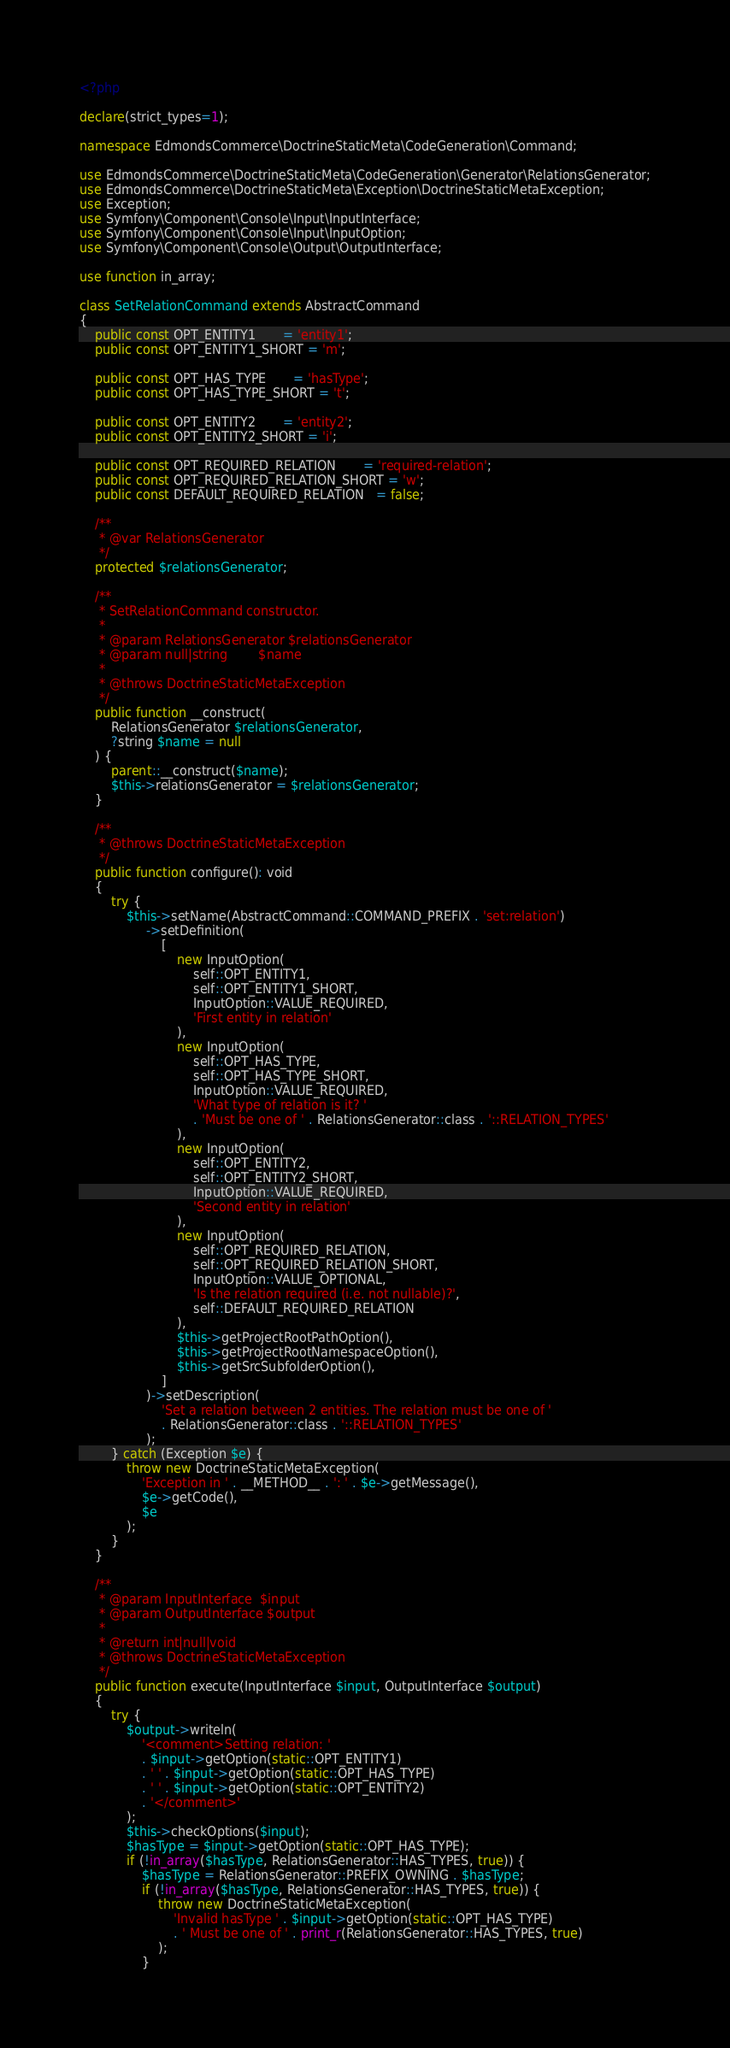Convert code to text. <code><loc_0><loc_0><loc_500><loc_500><_PHP_><?php

declare(strict_types=1);

namespace EdmondsCommerce\DoctrineStaticMeta\CodeGeneration\Command;

use EdmondsCommerce\DoctrineStaticMeta\CodeGeneration\Generator\RelationsGenerator;
use EdmondsCommerce\DoctrineStaticMeta\Exception\DoctrineStaticMetaException;
use Exception;
use Symfony\Component\Console\Input\InputInterface;
use Symfony\Component\Console\Input\InputOption;
use Symfony\Component\Console\Output\OutputInterface;

use function in_array;

class SetRelationCommand extends AbstractCommand
{
    public const OPT_ENTITY1       = 'entity1';
    public const OPT_ENTITY1_SHORT = 'm';

    public const OPT_HAS_TYPE       = 'hasType';
    public const OPT_HAS_TYPE_SHORT = 't';

    public const OPT_ENTITY2       = 'entity2';
    public const OPT_ENTITY2_SHORT = 'i';

    public const OPT_REQUIRED_RELATION       = 'required-relation';
    public const OPT_REQUIRED_RELATION_SHORT = 'w';
    public const DEFAULT_REQUIRED_RELATION   = false;

    /**
     * @var RelationsGenerator
     */
    protected $relationsGenerator;

    /**
     * SetRelationCommand constructor.
     *
     * @param RelationsGenerator $relationsGenerator
     * @param null|string        $name
     *
     * @throws DoctrineStaticMetaException
     */
    public function __construct(
        RelationsGenerator $relationsGenerator,
        ?string $name = null
    ) {
        parent::__construct($name);
        $this->relationsGenerator = $relationsGenerator;
    }

    /**
     * @throws DoctrineStaticMetaException
     */
    public function configure(): void
    {
        try {
            $this->setName(AbstractCommand::COMMAND_PREFIX . 'set:relation')
                 ->setDefinition(
                     [
                         new InputOption(
                             self::OPT_ENTITY1,
                             self::OPT_ENTITY1_SHORT,
                             InputOption::VALUE_REQUIRED,
                             'First entity in relation'
                         ),
                         new InputOption(
                             self::OPT_HAS_TYPE,
                             self::OPT_HAS_TYPE_SHORT,
                             InputOption::VALUE_REQUIRED,
                             'What type of relation is it? '
                             . 'Must be one of ' . RelationsGenerator::class . '::RELATION_TYPES'
                         ),
                         new InputOption(
                             self::OPT_ENTITY2,
                             self::OPT_ENTITY2_SHORT,
                             InputOption::VALUE_REQUIRED,
                             'Second entity in relation'
                         ),
                         new InputOption(
                             self::OPT_REQUIRED_RELATION,
                             self::OPT_REQUIRED_RELATION_SHORT,
                             InputOption::VALUE_OPTIONAL,
                             'Is the relation required (i.e. not nullable)?',
                             self::DEFAULT_REQUIRED_RELATION
                         ),
                         $this->getProjectRootPathOption(),
                         $this->getProjectRootNamespaceOption(),
                         $this->getSrcSubfolderOption(),
                     ]
                 )->setDescription(
                     'Set a relation between 2 entities. The relation must be one of '
                     . RelationsGenerator::class . '::RELATION_TYPES'
                 );
        } catch (Exception $e) {
            throw new DoctrineStaticMetaException(
                'Exception in ' . __METHOD__ . ': ' . $e->getMessage(),
                $e->getCode(),
                $e
            );
        }
    }

    /**
     * @param InputInterface  $input
     * @param OutputInterface $output
     *
     * @return int|null|void
     * @throws DoctrineStaticMetaException
     */
    public function execute(InputInterface $input, OutputInterface $output)
    {
        try {
            $output->writeln(
                '<comment>Setting relation: '
                . $input->getOption(static::OPT_ENTITY1)
                . ' ' . $input->getOption(static::OPT_HAS_TYPE)
                . ' ' . $input->getOption(static::OPT_ENTITY2)
                . '</comment>'
            );
            $this->checkOptions($input);
            $hasType = $input->getOption(static::OPT_HAS_TYPE);
            if (!in_array($hasType, RelationsGenerator::HAS_TYPES, true)) {
                $hasType = RelationsGenerator::PREFIX_OWNING . $hasType;
                if (!in_array($hasType, RelationsGenerator::HAS_TYPES, true)) {
                    throw new DoctrineStaticMetaException(
                        'Invalid hasType ' . $input->getOption(static::OPT_HAS_TYPE)
                        . ' Must be one of ' . print_r(RelationsGenerator::HAS_TYPES, true)
                    );
                }</code> 